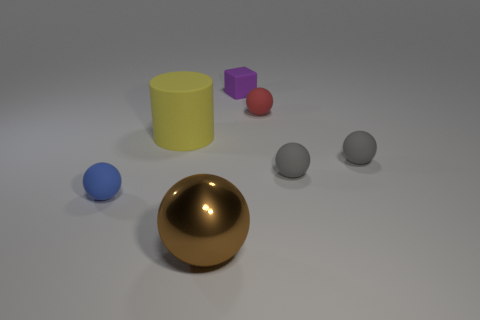The shiny object that is the same shape as the blue rubber object is what size?
Provide a succinct answer. Large. Is there anything else that is the same size as the red object?
Make the answer very short. Yes. Is the size of the rubber cylinder the same as the rubber object behind the tiny red rubber sphere?
Your answer should be very brief. No. The large thing in front of the blue thing has what shape?
Your response must be concise. Sphere. What is the color of the sphere in front of the rubber ball that is left of the purple rubber cube?
Keep it short and to the point. Brown. There is another shiny object that is the same shape as the tiny red thing; what color is it?
Your answer should be very brief. Brown. Is the color of the big matte thing the same as the small sphere that is to the left of the tiny purple rubber object?
Provide a short and direct response. No. There is a thing that is behind the rubber cylinder and in front of the purple cube; what is its shape?
Provide a short and direct response. Sphere. What material is the big thing left of the object in front of the tiny rubber object left of the brown thing?
Provide a succinct answer. Rubber. Is the number of tiny red spheres that are in front of the purple matte block greater than the number of small matte balls that are to the left of the tiny red thing?
Offer a very short reply. No. 